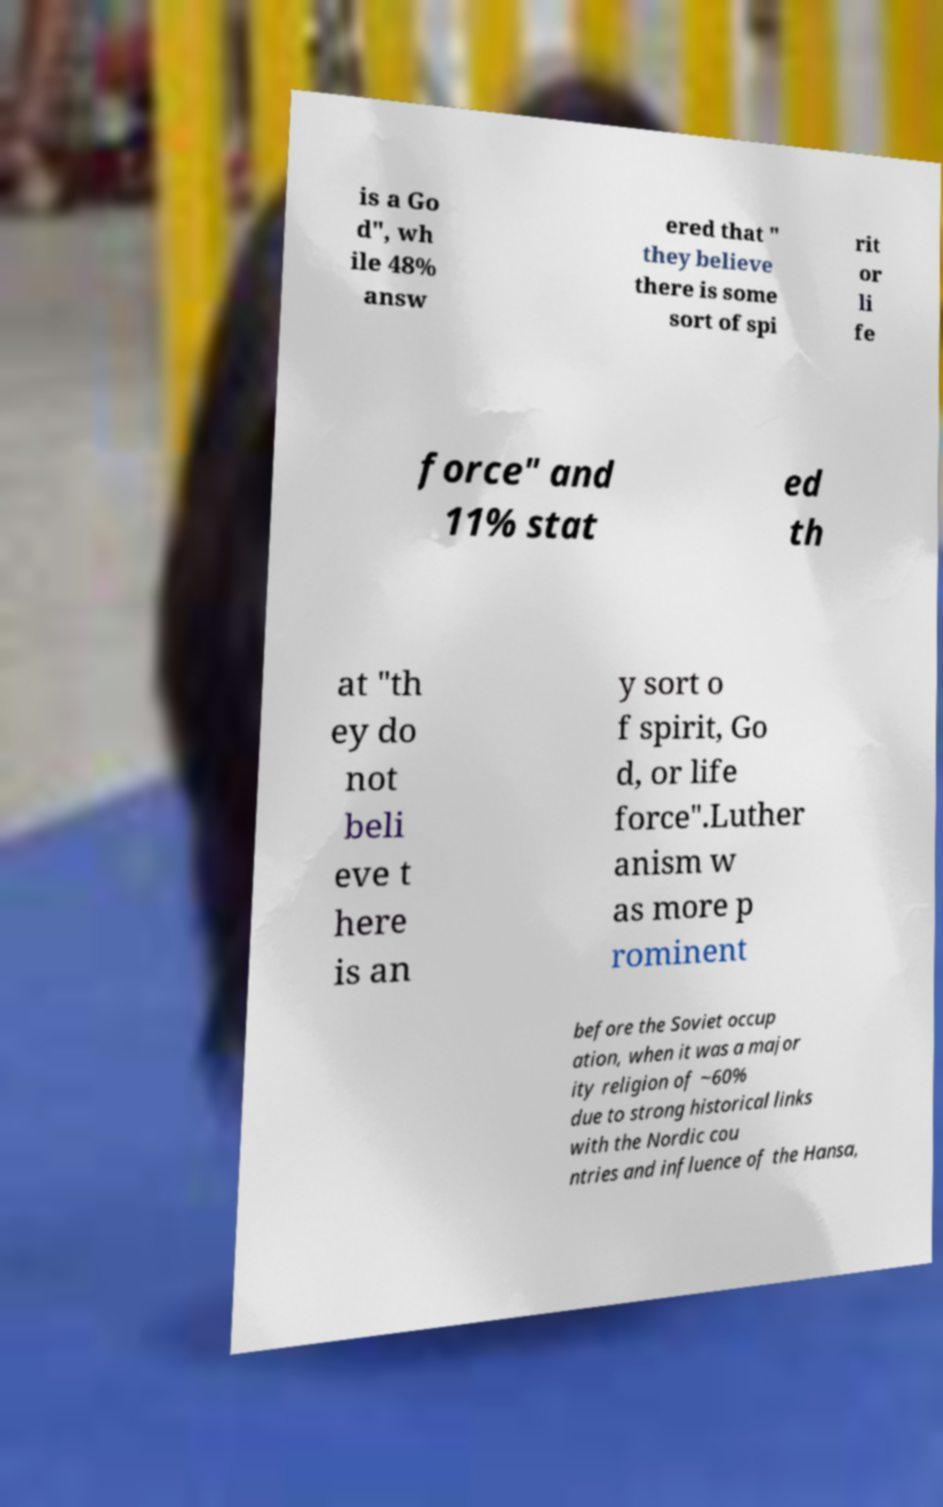Please identify and transcribe the text found in this image. is a Go d", wh ile 48% answ ered that " they believe there is some sort of spi rit or li fe force" and 11% stat ed th at "th ey do not beli eve t here is an y sort o f spirit, Go d, or life force".Luther anism w as more p rominent before the Soviet occup ation, when it was a major ity religion of ~60% due to strong historical links with the Nordic cou ntries and influence of the Hansa, 